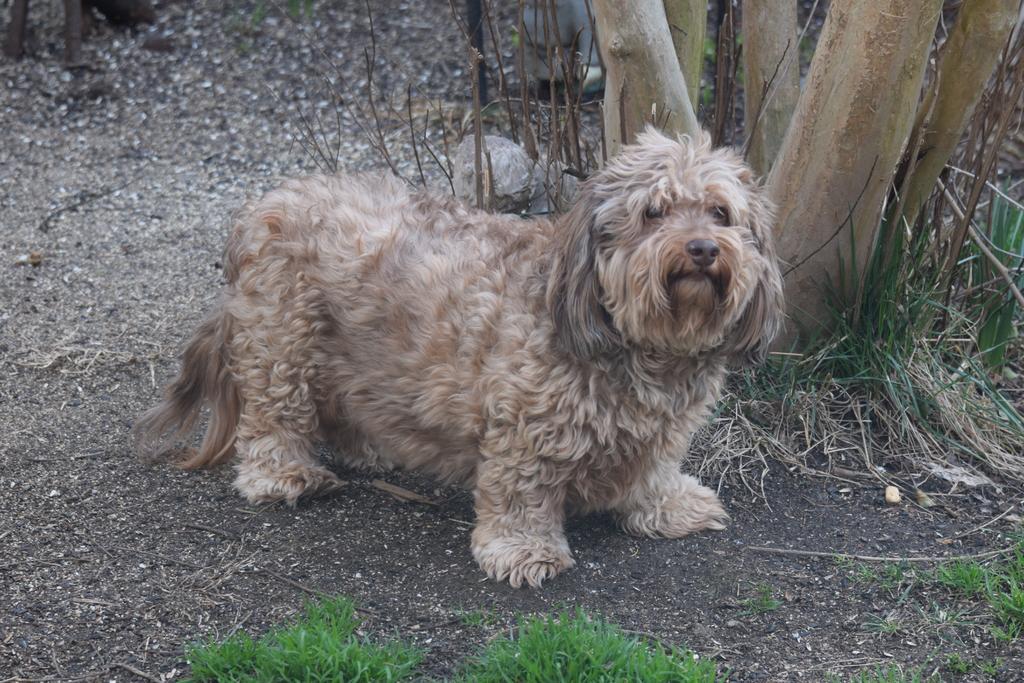Please provide a concise description of this image. In this image I can see a cream colored dog is standing. I can also see grass and tree trunks. 